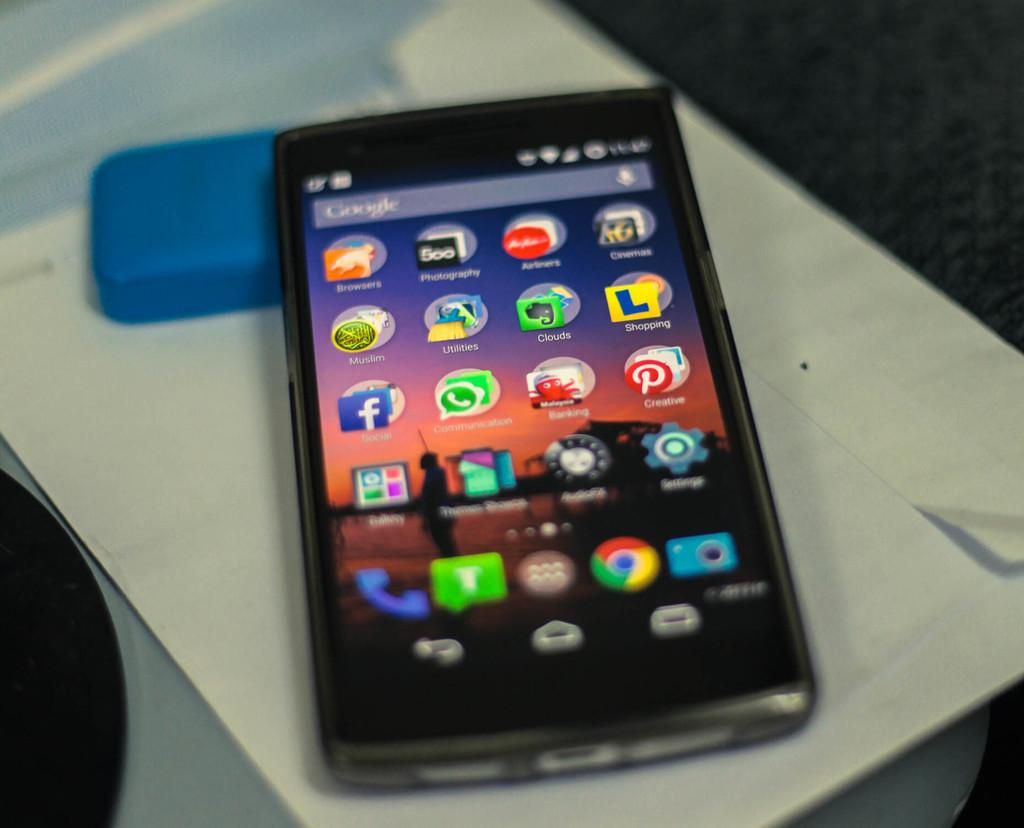<image>
Relay a brief, clear account of the picture shown. the name Google is on the front of the phone 